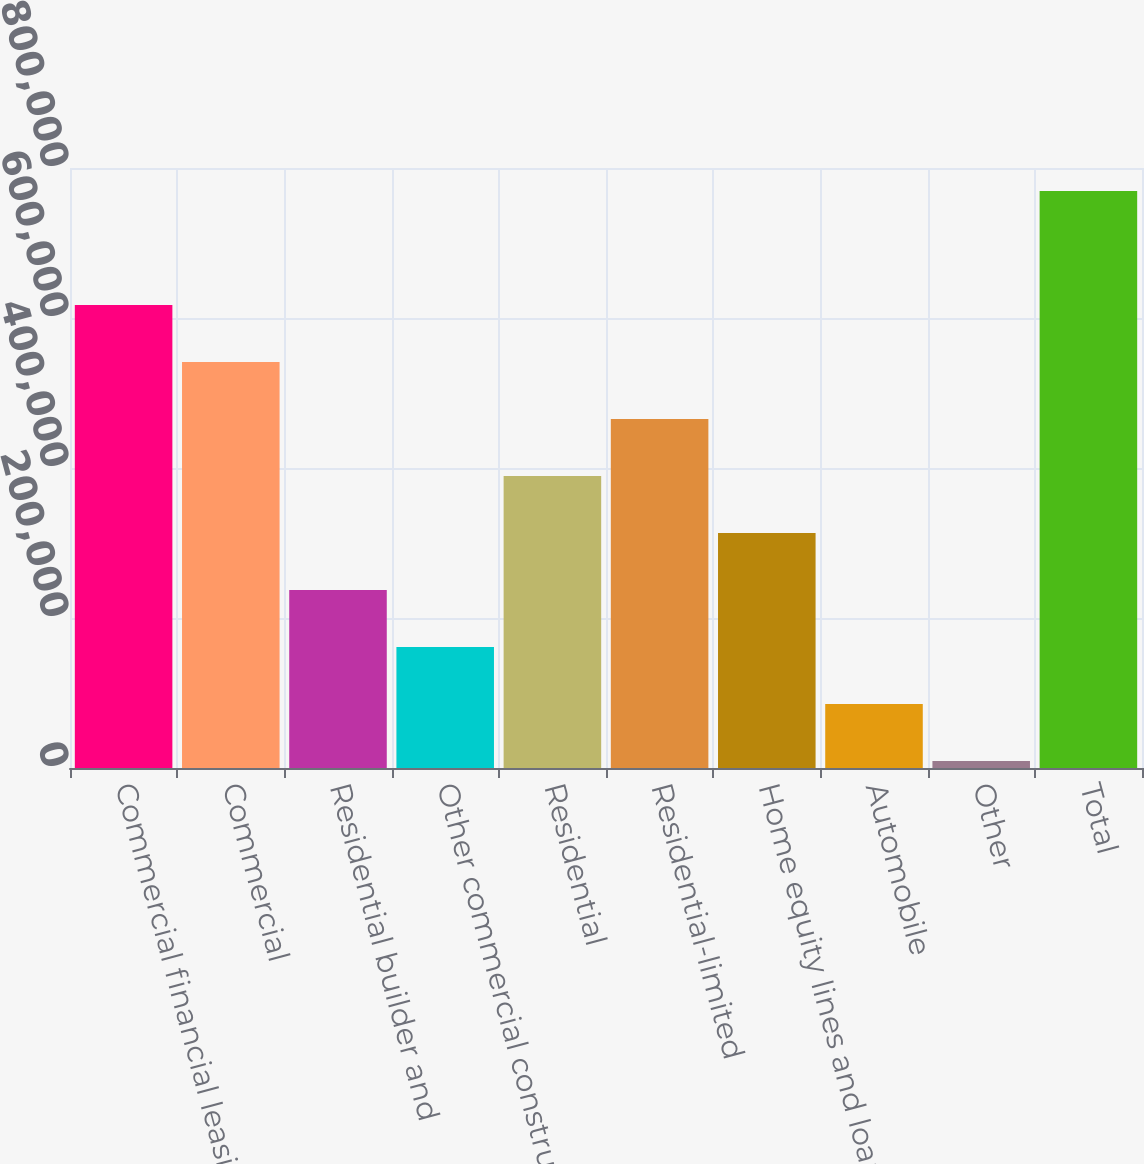Convert chart. <chart><loc_0><loc_0><loc_500><loc_500><bar_chart><fcel>Commercial financial leasing<fcel>Commercial<fcel>Residential builder and<fcel>Other commercial construction<fcel>Residential<fcel>Residential-limited<fcel>Home equity lines and loans<fcel>Automobile<fcel>Other<fcel>Total<nl><fcel>617251<fcel>541247<fcel>237230<fcel>161226<fcel>389238<fcel>465243<fcel>313234<fcel>85222.1<fcel>9218<fcel>769259<nl></chart> 